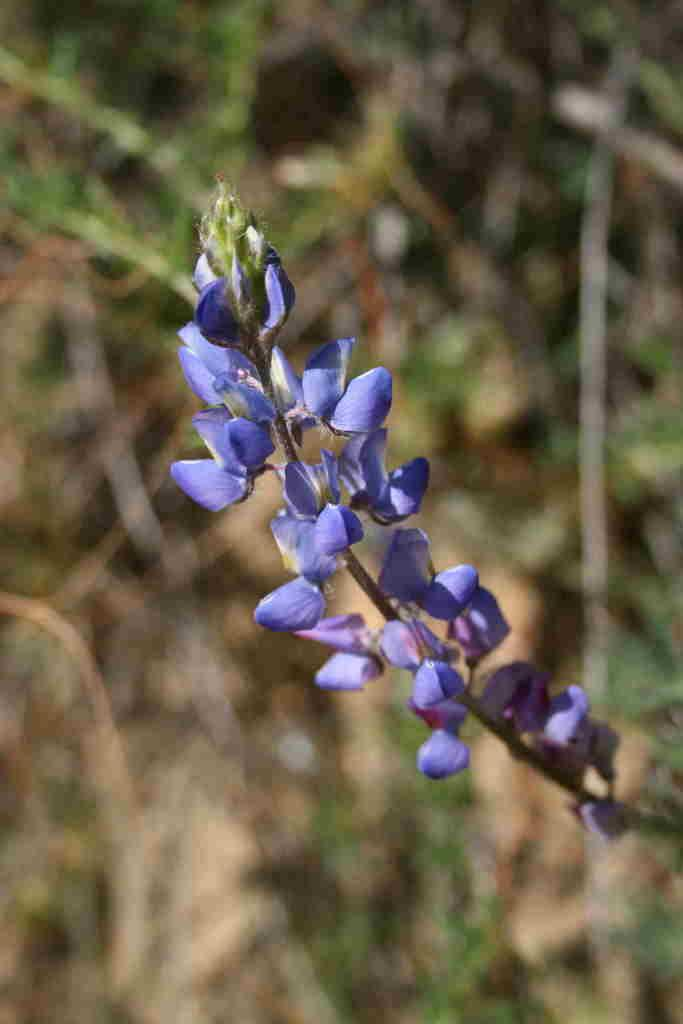What color are the flowers on the plant in the image? The flowers on the plant in the image are violet. Can you describe any other plants in the image? There are other plants visible in the background of the image, although they appear blurred. What type of dinner is being served at the club in the image? There is no dinner or club present in the image; it features violet flowers on a plant and other blurred plants in the background. 